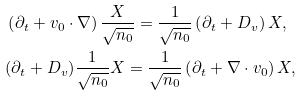Convert formula to latex. <formula><loc_0><loc_0><loc_500><loc_500>& \left ( \partial _ { t } + { v } _ { 0 } \cdot \nabla \right ) \frac { X } { \sqrt { n _ { 0 } } } = \frac { 1 } { \sqrt { n _ { 0 } } } \left ( \partial _ { t } + D _ { v } \right ) X , \\ & ( \partial _ { t } + D _ { v } ) \frac { 1 } { \sqrt { n _ { 0 } } } X = \frac { 1 } { \sqrt { n _ { 0 } } } \left ( \partial _ { t } + \nabla \cdot { v } _ { 0 } \right ) X ,</formula> 